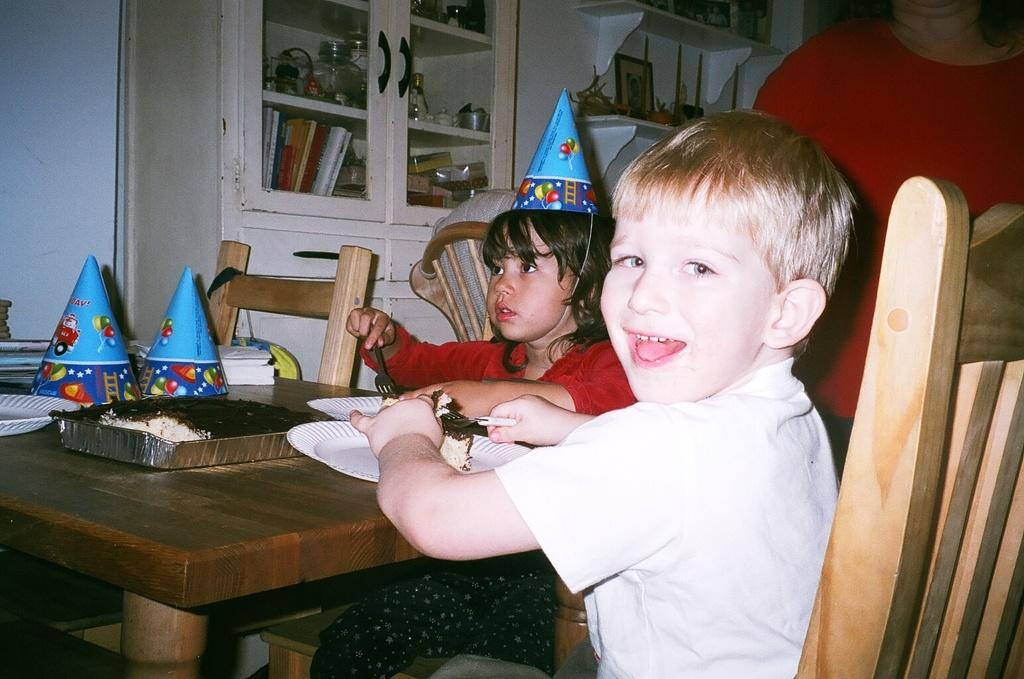How many children are in the image? There are two children in the image. What are the children holding in their hands? The children are holding forks in their hands. What objects are visible on the table in the image? There are plates visible in the image. What type of clothing accessory can be seen on the children's heads? There are caps in the image. Who else is present in the image besides the children? There is a woman in the image. How many chairs are in the image? There are four chairs in the image. What type of glue is being used to hold the cloud in the image? There is no cloud or glue present in the image. How many spoons are visible in the image? The provided facts do not mention spoons, so we cannot determine the number of spoons in the image. 